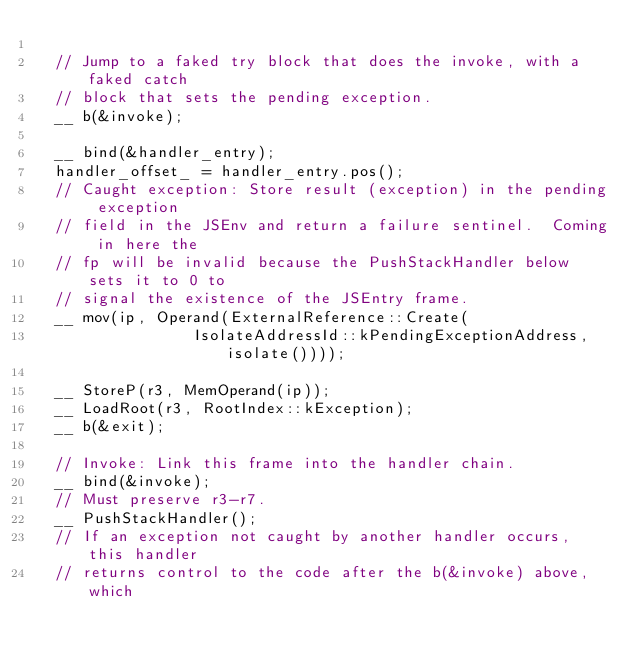Convert code to text. <code><loc_0><loc_0><loc_500><loc_500><_C++_>
  // Jump to a faked try block that does the invoke, with a faked catch
  // block that sets the pending exception.
  __ b(&invoke);

  __ bind(&handler_entry);
  handler_offset_ = handler_entry.pos();
  // Caught exception: Store result (exception) in the pending exception
  // field in the JSEnv and return a failure sentinel.  Coming in here the
  // fp will be invalid because the PushStackHandler below sets it to 0 to
  // signal the existence of the JSEntry frame.
  __ mov(ip, Operand(ExternalReference::Create(
                 IsolateAddressId::kPendingExceptionAddress, isolate())));

  __ StoreP(r3, MemOperand(ip));
  __ LoadRoot(r3, RootIndex::kException);
  __ b(&exit);

  // Invoke: Link this frame into the handler chain.
  __ bind(&invoke);
  // Must preserve r3-r7.
  __ PushStackHandler();
  // If an exception not caught by another handler occurs, this handler
  // returns control to the code after the b(&invoke) above, which</code> 